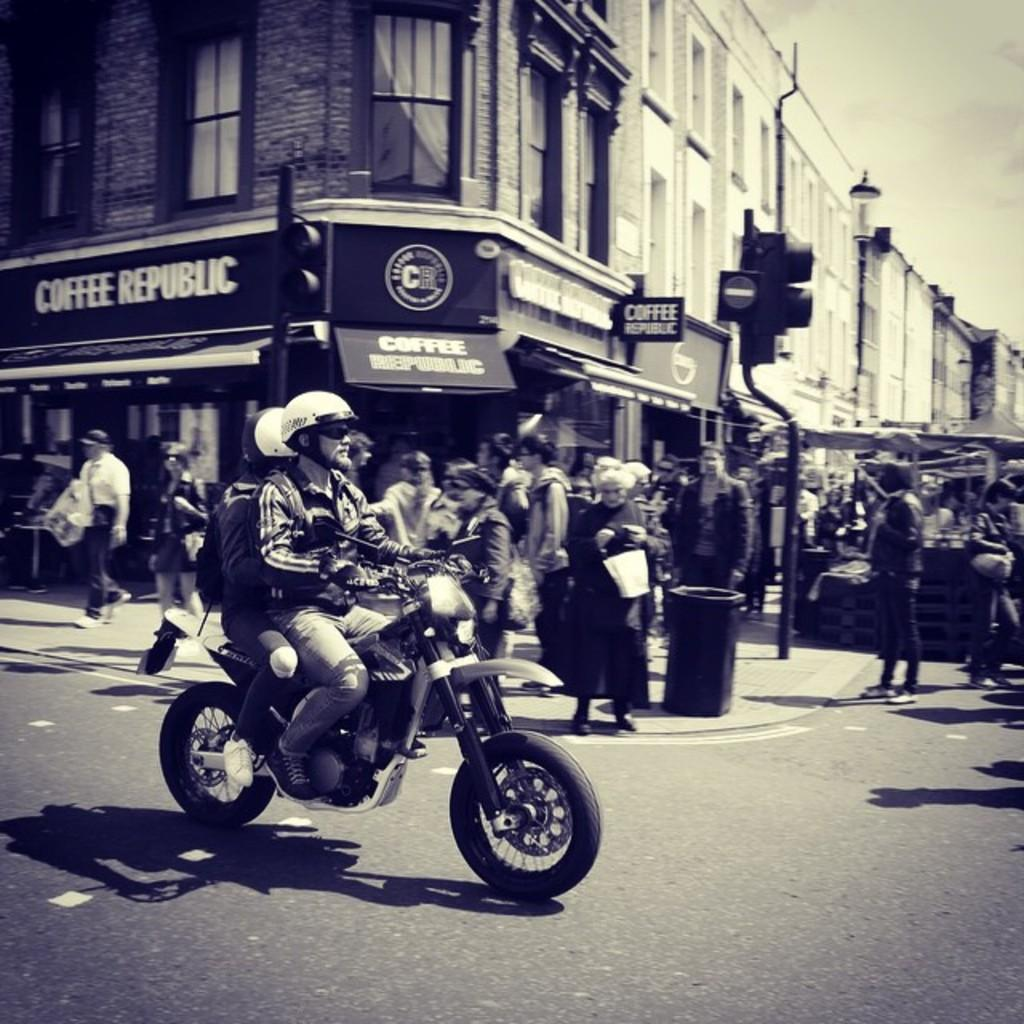What is the main subject of the image? There is a man on a motorcycle in the image. What is the man on the motorcycle doing? The man is moving on the road. What can be seen on the side of the road? There are people standing on the side of the road and a building. What helps regulate traffic in the image? There are traffic lights visible in the image. Can you see the fang of the snake on the side of the road in the image? There is no snake or fang present in the image. What expression does the moon have in the image? The image does not show the moon; it features a man on a motorcycle, people, a building, and traffic lights. 